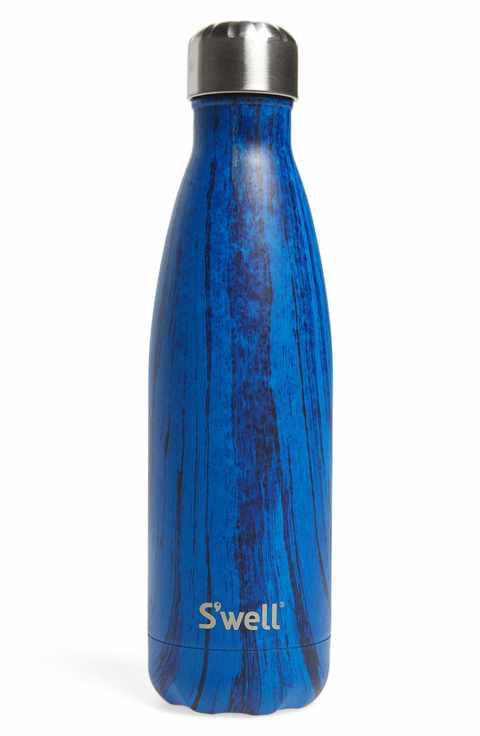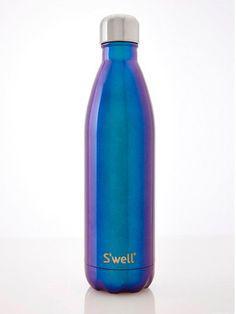The first image is the image on the left, the second image is the image on the right. For the images shown, is this caption "The image on the left contains a dark blue bottle." true? Answer yes or no. Yes. 